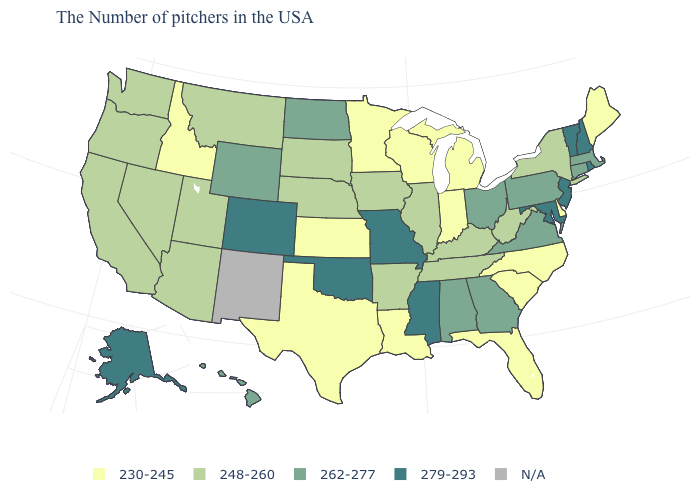Name the states that have a value in the range 248-260?
Short answer required. New York, West Virginia, Kentucky, Tennessee, Illinois, Arkansas, Iowa, Nebraska, South Dakota, Utah, Montana, Arizona, Nevada, California, Washington, Oregon. Name the states that have a value in the range N/A?
Write a very short answer. New Mexico. What is the value of South Carolina?
Short answer required. 230-245. Among the states that border Missouri , does Oklahoma have the highest value?
Quick response, please. Yes. Does South Carolina have the lowest value in the South?
Short answer required. Yes. What is the value of Oregon?
Concise answer only. 248-260. Name the states that have a value in the range 248-260?
Short answer required. New York, West Virginia, Kentucky, Tennessee, Illinois, Arkansas, Iowa, Nebraska, South Dakota, Utah, Montana, Arizona, Nevada, California, Washington, Oregon. What is the highest value in states that border Pennsylvania?
Concise answer only. 279-293. Name the states that have a value in the range 248-260?
Short answer required. New York, West Virginia, Kentucky, Tennessee, Illinois, Arkansas, Iowa, Nebraska, South Dakota, Utah, Montana, Arizona, Nevada, California, Washington, Oregon. What is the value of Washington?
Concise answer only. 248-260. What is the value of New Mexico?
Be succinct. N/A. Among the states that border Maine , which have the lowest value?
Be succinct. New Hampshire. 